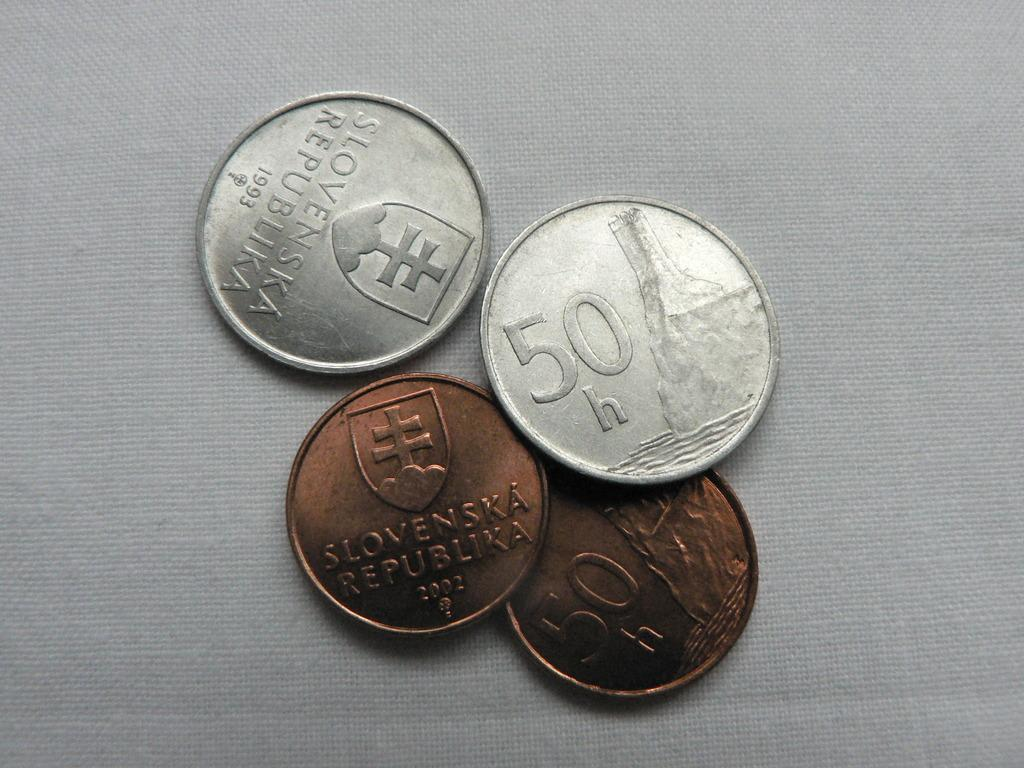How many coins are present in the image? There are four coins in the image. What is the color of the cloth on which the coins are placed? The coins are visible on a white color cloth. What type of shoe is visible in the image? There is no shoe present in the image; it only features four coins on a white color cloth. 